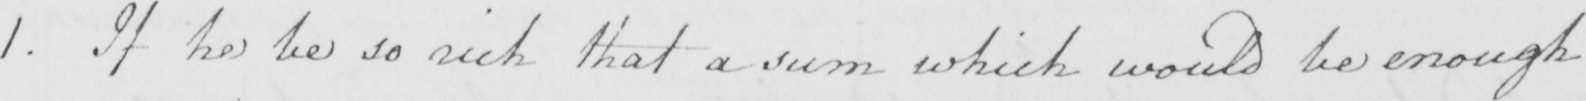Please transcribe the handwritten text in this image. 1 . If he be so rich that a sum which would be enough 